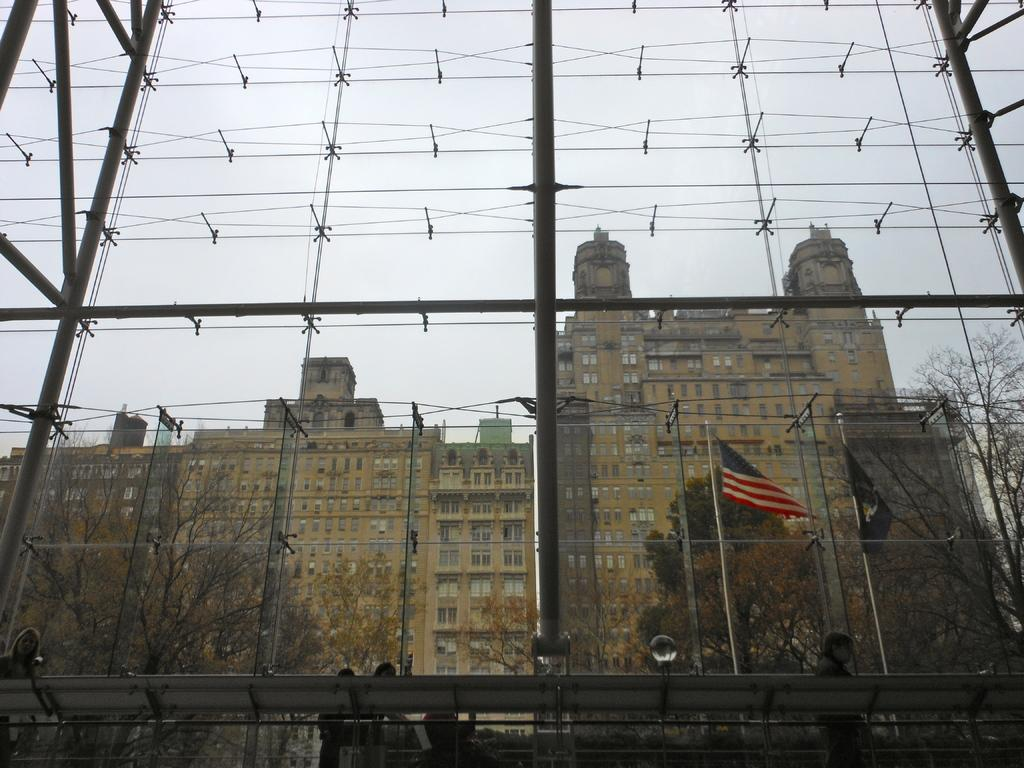What type of barrier can be seen in the image? There is a metal fence in the image. Who or what is present in the image? There are people in the image. What can be seen in the background of the image? There are flags, buildings, trees, and the sky visible in the background of the image. What type of lumber is being used to construct the buildings in the image? There is no information about the type of lumber used in the construction of the buildings in the image. 